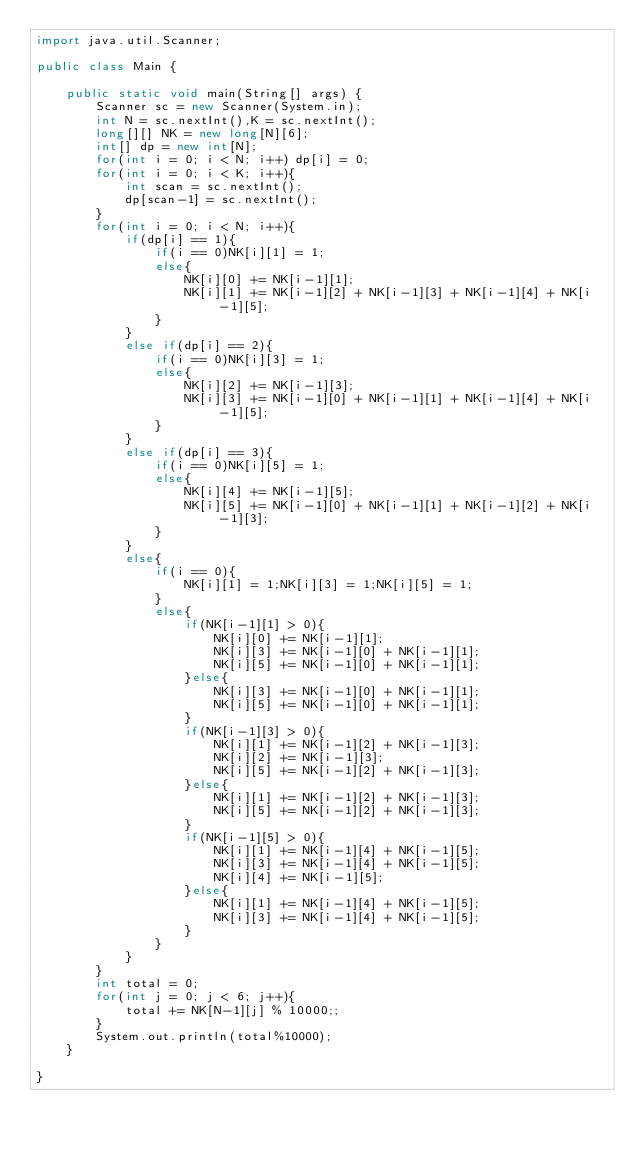Convert code to text. <code><loc_0><loc_0><loc_500><loc_500><_Java_>import java.util.Scanner;

public class Main {

	public static void main(String[] args) {
		Scanner sc = new Scanner(System.in);
		int N = sc.nextInt(),K = sc.nextInt(); 
		long[][] NK = new long[N][6]; 
		int[] dp = new int[N]; 
		for(int i = 0; i < N; i++) dp[i] = 0;
		for(int i = 0; i < K; i++){
			int scan = sc.nextInt();
			dp[scan-1] = sc.nextInt();
		} 
		for(int i = 0; i < N; i++){
			if(dp[i] == 1){
				if(i == 0)NK[i][1] = 1;
				else{
					NK[i][0] += NK[i-1][1];
					NK[i][1] += NK[i-1][2] + NK[i-1][3] + NK[i-1][4] + NK[i-1][5];
				}
			}
			else if(dp[i] == 2){
				if(i == 0)NK[i][3] = 1;
				else{
					NK[i][2] += NK[i-1][3];
					NK[i][3] += NK[i-1][0] + NK[i-1][1] + NK[i-1][4] + NK[i-1][5];
				}
			}
			else if(dp[i] == 3){
				if(i == 0)NK[i][5] = 1;
				else{
					NK[i][4] += NK[i-1][5];
					NK[i][5] += NK[i-1][0] + NK[i-1][1] + NK[i-1][2] + NK[i-1][3];
				}
			}
			else{
				if(i == 0){
					NK[i][1] = 1;NK[i][3] = 1;NK[i][5] = 1;
				}
				else{
					if(NK[i-1][1] > 0){
						NK[i][0] += NK[i-1][1];
						NK[i][3] += NK[i-1][0] + NK[i-1][1];
						NK[i][5] += NK[i-1][0] + NK[i-1][1];
					}else{
						NK[i][3] += NK[i-1][0] + NK[i-1][1];
						NK[i][5] += NK[i-1][0] + NK[i-1][1];
					}
					if(NK[i-1][3] > 0){
						NK[i][1] += NK[i-1][2] + NK[i-1][3];
						NK[i][2] += NK[i-1][3];
						NK[i][5] += NK[i-1][2] + NK[i-1][3];
					}else{
						NK[i][1] += NK[i-1][2] + NK[i-1][3];
						NK[i][5] += NK[i-1][2] + NK[i-1][3];
					}
					if(NK[i-1][5] > 0){
						NK[i][1] += NK[i-1][4] + NK[i-1][5];
						NK[i][3] += NK[i-1][4] + NK[i-1][5];
						NK[i][4] += NK[i-1][5];
					}else{
						NK[i][1] += NK[i-1][4] + NK[i-1][5];
						NK[i][3] += NK[i-1][4] + NK[i-1][5];
					}
				}
			}
		}
		int total = 0;
		for(int j = 0; j < 6; j++){
			total += NK[N-1][j] % 10000;; 
		}
		System.out.println(total%10000);
	}

}</code> 